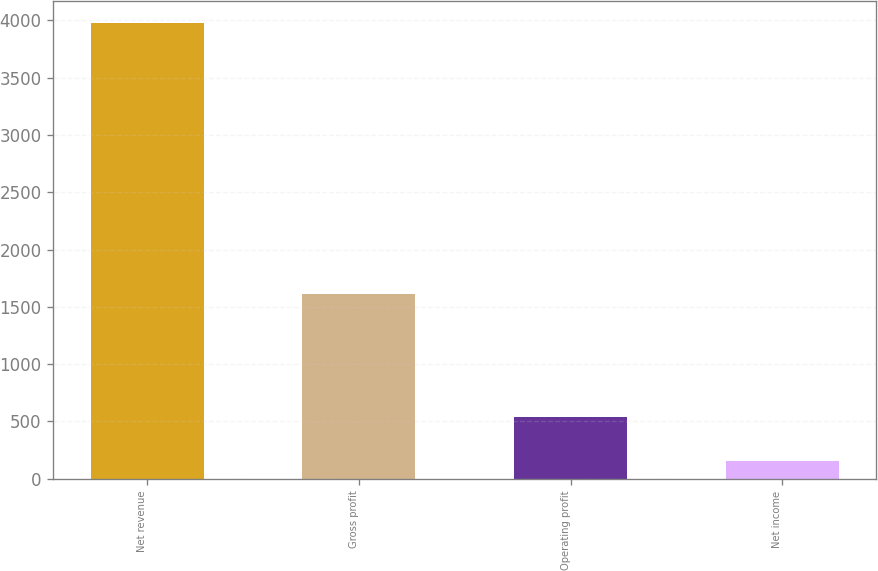Convert chart. <chart><loc_0><loc_0><loc_500><loc_500><bar_chart><fcel>Net revenue<fcel>Gross profit<fcel>Operating profit<fcel>Net income<nl><fcel>3972<fcel>1608<fcel>539.4<fcel>158<nl></chart> 